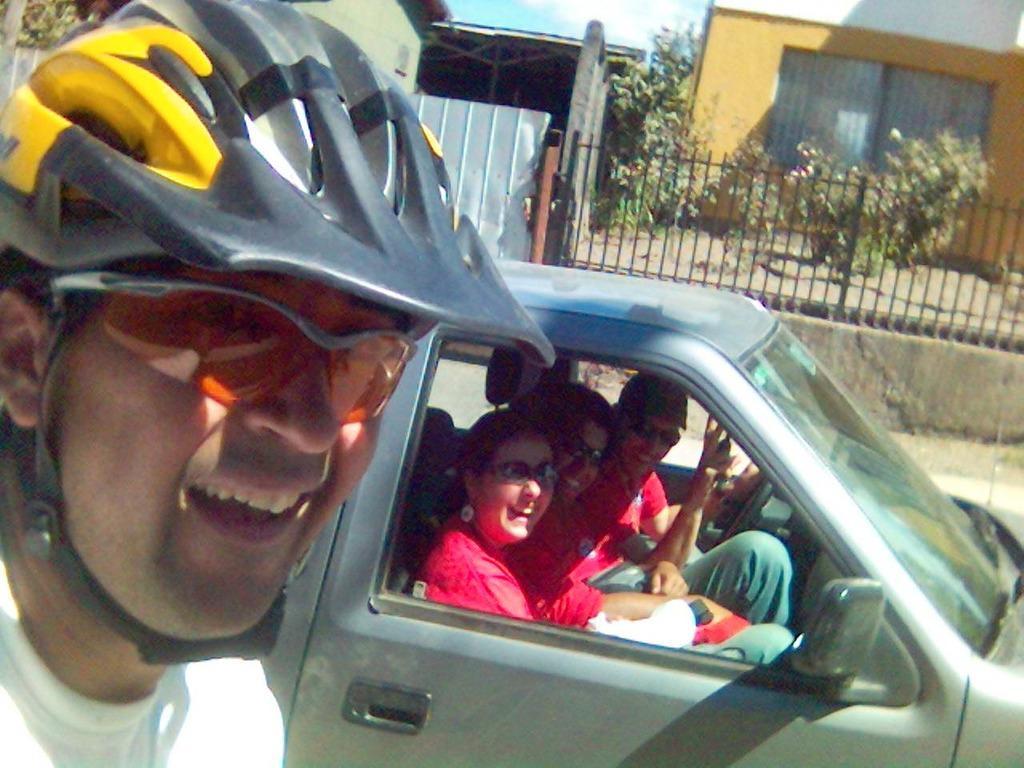Can you describe this image briefly? On the left side there is a person wearing goggles and helmets. In the back there are three persons wearing goggles are sitting in the car. In the background there is railing, trees and building 